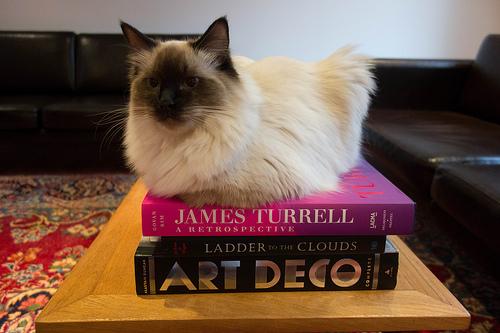<image>
Is there a cat in the book? No. The cat is not contained within the book. These objects have a different spatial relationship. 